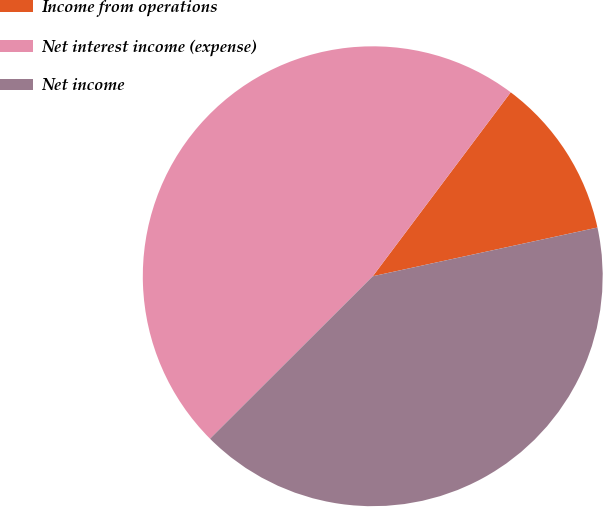<chart> <loc_0><loc_0><loc_500><loc_500><pie_chart><fcel>Income from operations<fcel>Net interest income (expense)<fcel>Net income<nl><fcel>11.36%<fcel>47.73%<fcel>40.91%<nl></chart> 